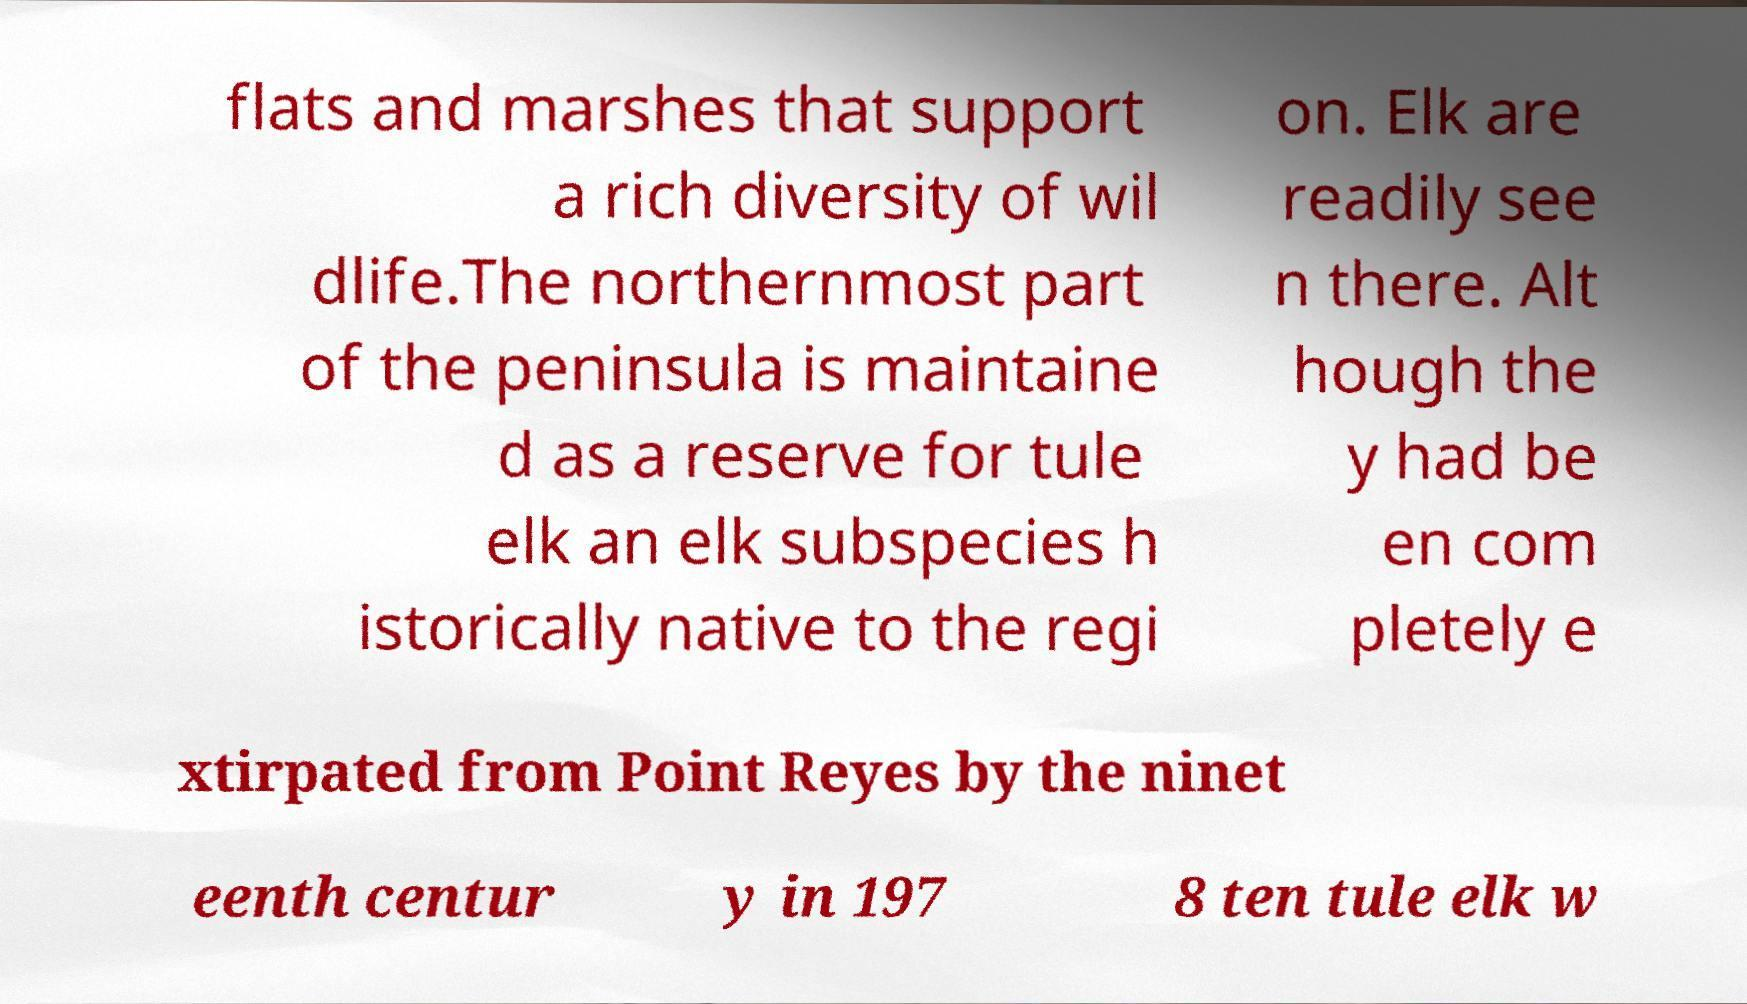I need the written content from this picture converted into text. Can you do that? flats and marshes that support a rich diversity of wil dlife.The northernmost part of the peninsula is maintaine d as a reserve for tule elk an elk subspecies h istorically native to the regi on. Elk are readily see n there. Alt hough the y had be en com pletely e xtirpated from Point Reyes by the ninet eenth centur y in 197 8 ten tule elk w 